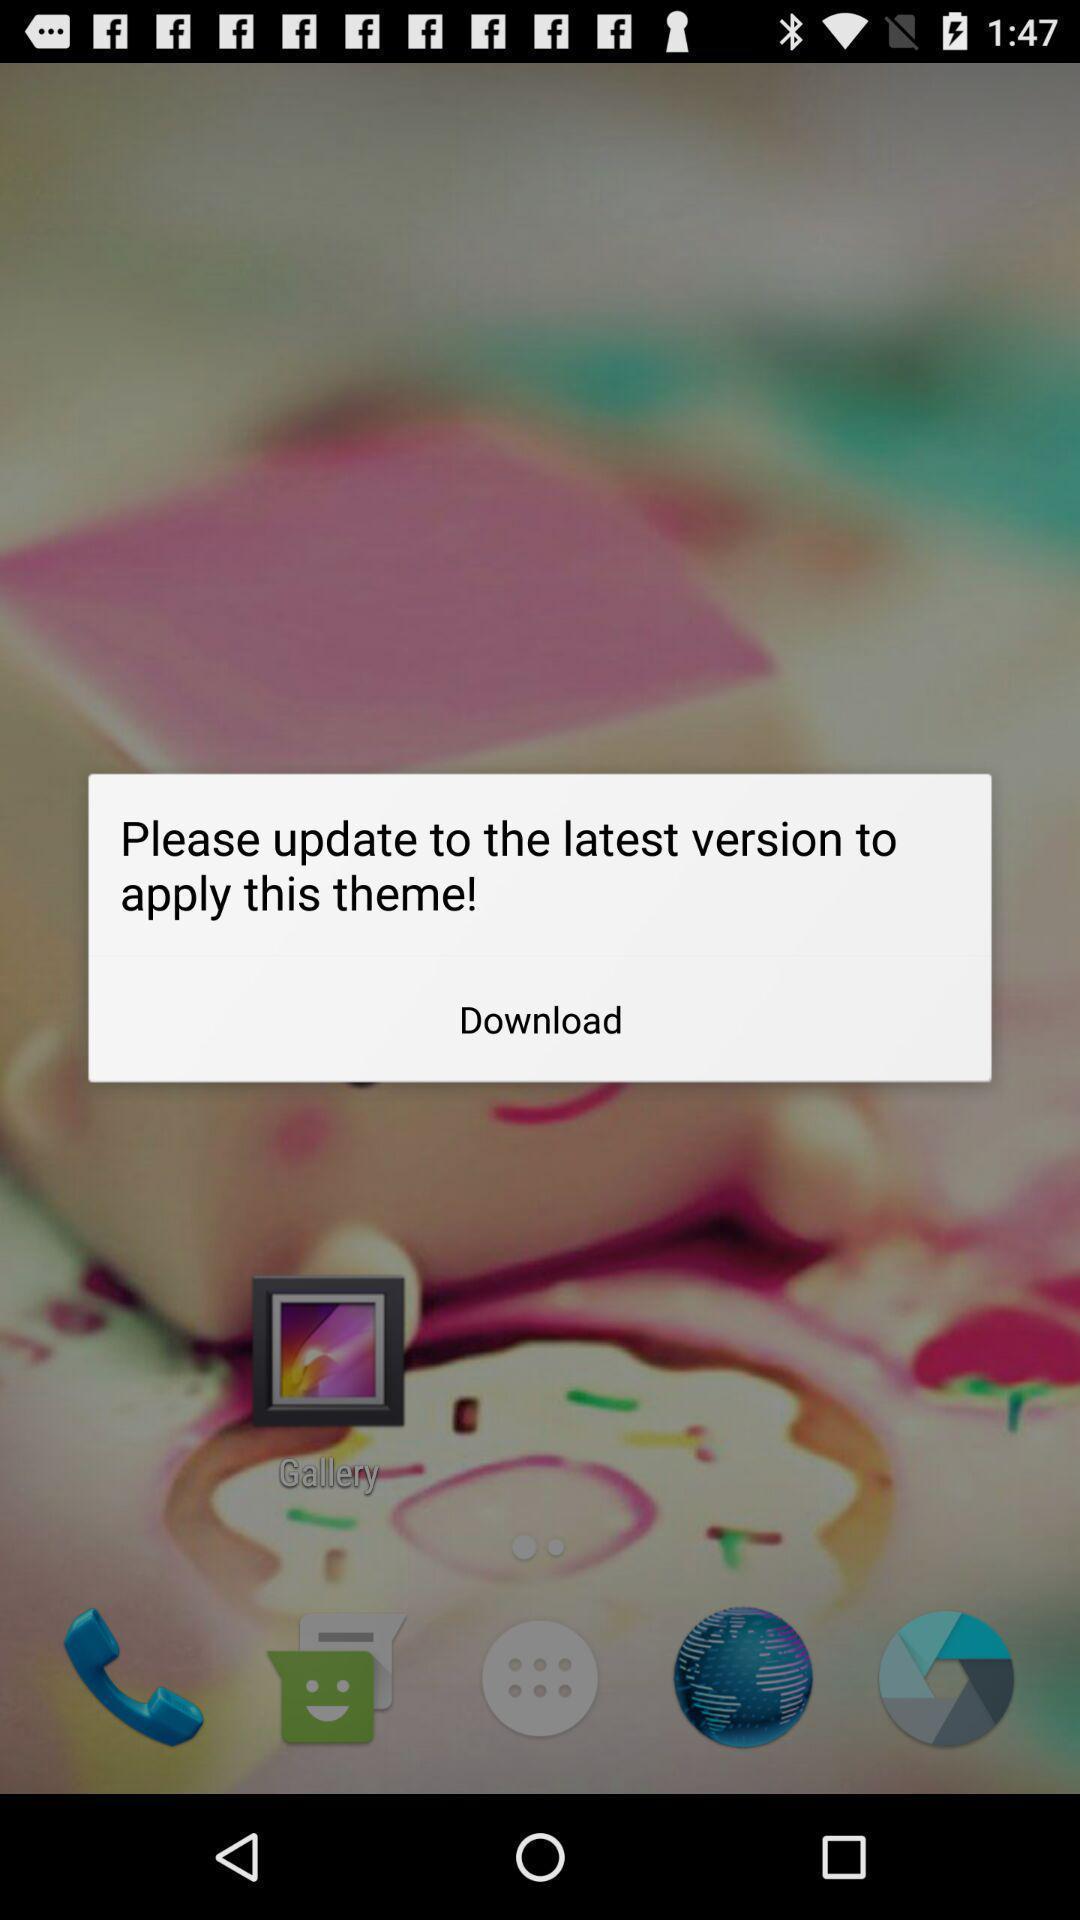Describe this image in words. Pop-up showing to update latest version. 